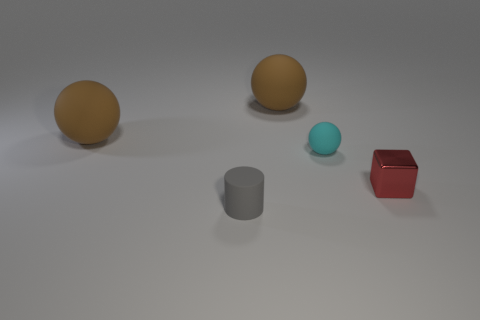Is there another large matte object of the same shape as the cyan rubber object?
Offer a terse response. Yes. How many things are either brown objects or gray matte cylinders?
Ensure brevity in your answer.  3. There is a tiny rubber thing in front of the tiny matte ball right of the small matte cylinder; what number of tiny red shiny objects are on the left side of it?
Ensure brevity in your answer.  0. There is a tiny thing that is on the right side of the small gray cylinder and to the left of the metallic block; what is its material?
Your answer should be very brief. Rubber. Are there fewer balls that are left of the small gray cylinder than spheres that are left of the metallic cube?
Provide a short and direct response. Yes. How many other objects are there of the same size as the matte cylinder?
Keep it short and to the point. 2. There is a large matte thing that is in front of the big brown sphere right of the thing in front of the red block; what is its shape?
Ensure brevity in your answer.  Sphere. What number of brown objects are metallic objects or large matte spheres?
Keep it short and to the point. 2. What number of red things are behind the brown sphere that is on the left side of the small gray object?
Your answer should be very brief. 0. Is there any other thing that has the same color as the rubber cylinder?
Make the answer very short. No. 